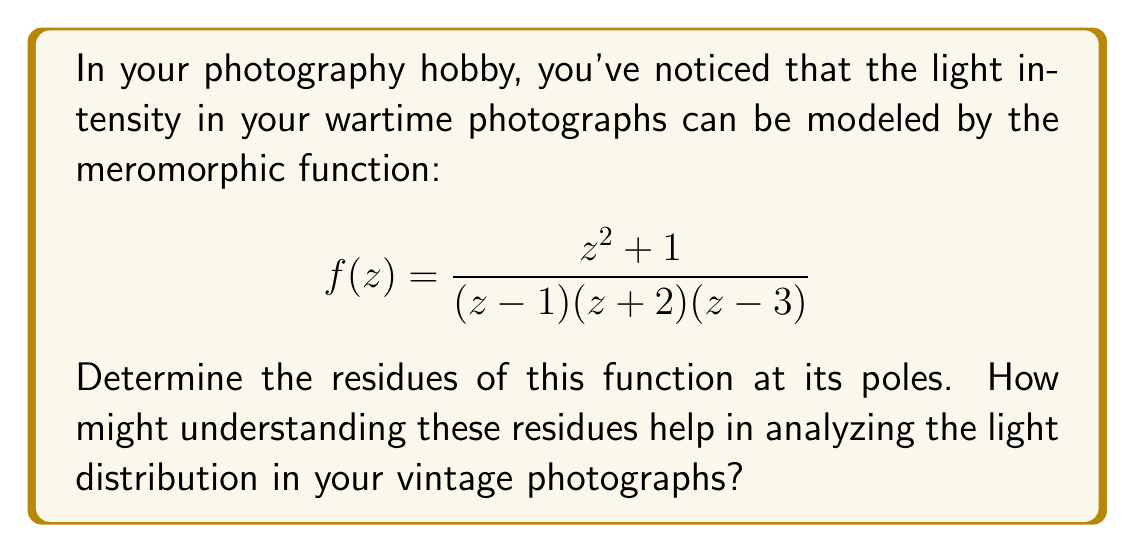Help me with this question. Let's approach this step-by-step:

1) First, we identify the poles of the function. They are at $z=1$, $z=-2$, and $z=3$. All of these are simple poles.

2) To find the residue at a simple pole $z=a$, we use the formula:
   $$\text{Res}(f,a) = \lim_{z \to a} (z-a)f(z)$$

3) For $z=1$:
   $$\begin{align}
   \text{Res}(f,1) &= \lim_{z \to 1} (z-1)\frac{z^2 + 1}{(z-1)(z+2)(z-3)} \\
   &= \lim_{z \to 1} \frac{z^2 + 1}{(z+2)(z-3)} \\
   &= \frac{1^2 + 1}{(1+2)(1-3)} = \frac{2}{(-6)} = -\frac{1}{3}
   \end{align}$$

4) For $z=-2$:
   $$\begin{align}
   \text{Res}(f,-2) &= \lim_{z \to -2} (z+2)\frac{z^2 + 1}{(z-1)(z+2)(z-3)} \\
   &= \lim_{z \to -2} \frac{z^2 + 1}{(z-1)(z-3)} \\
   &= \frac{(-2)^2 + 1}{(-2-1)(-2-3)} = \frac{5}{15} = \frac{1}{3}
   \end{align}$$

5) For $z=3$:
   $$\begin{align}
   \text{Res}(f,3) &= \lim_{z \to 3} (z-3)\frac{z^2 + 1}{(z-1)(z+2)(z-3)} \\
   &= \lim_{z \to 3} \frac{z^2 + 1}{(z-1)(z+2)} \\
   &= \frac{3^2 + 1}{(3-1)(3+2)} = \frac{10}{10} = 1
   \end{align}$$

Understanding these residues can help in analyzing light distribution in vintage photographs. The residues give information about the behavior of the function near its poles, which in this context represent areas of rapid change in light intensity. Positive residues might indicate areas of light concentration, while negative residues could represent areas of light scarcity. The magnitude of the residues could correlate with the strength of these light effects in the photograph.
Answer: The residues of the function are:
$$\text{Res}(f,1) = -\frac{1}{3}, \quad \text{Res}(f,-2) = \frac{1}{3}, \quad \text{Res}(f,3) = 1$$ 